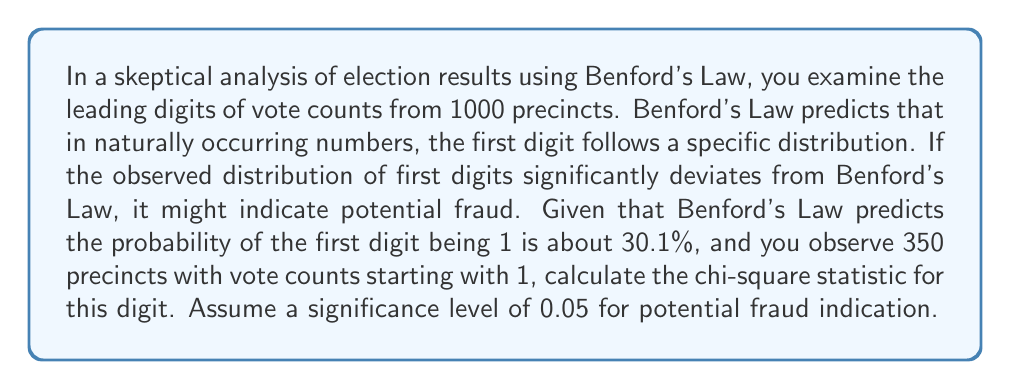Show me your answer to this math problem. To calculate the chi-square statistic for the first digit, we'll follow these steps:

1) Expected frequency for digit 1:
   $E = 1000 \times 0.301 = 301$

2) Observed frequency for digit 1:
   $O = 350$

3) The chi-square statistic for a single category is calculated as:
   $$\chi^2 = \frac{(O - E)^2}{E}$$

4) Substituting our values:
   $$\chi^2 = \frac{(350 - 301)^2}{301} = \frac{2401}{301} \approx 7.9768$$

5) For a single degree of freedom (we're only looking at one digit), the critical value at a 0.05 significance level is 3.841.

6) Since our calculated $\chi^2$ (7.9768) is greater than the critical value (3.841), this indicates a significant deviation from Benford's Law for the first digit.

Note: This analysis alone doesn't prove fraud. It merely suggests that further investigation might be warranted, as there could be other explanations for the deviation.
Answer: $\chi^2 \approx 7.9768$ 